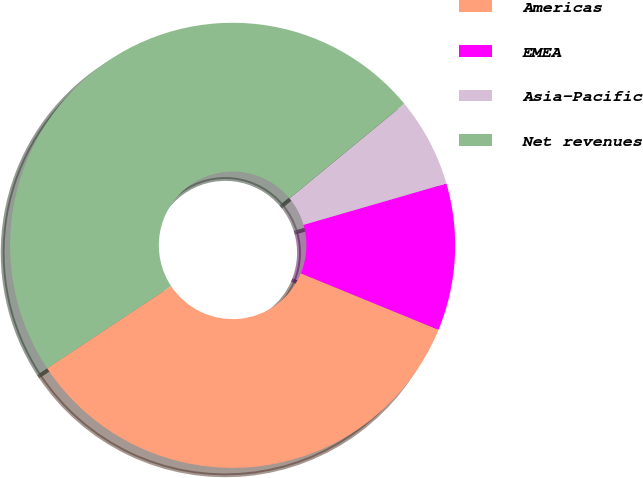<chart> <loc_0><loc_0><loc_500><loc_500><pie_chart><fcel>Americas<fcel>EMEA<fcel>Asia-Pacific<fcel>Net revenues<nl><fcel>34.49%<fcel>10.68%<fcel>6.49%<fcel>48.34%<nl></chart> 